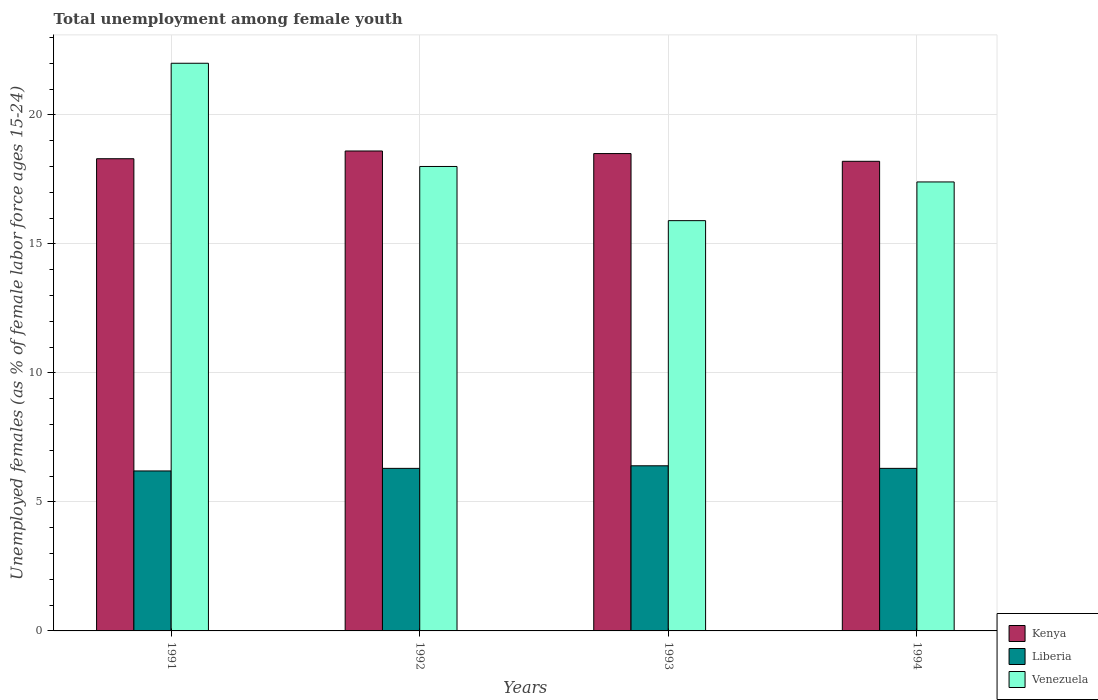Are the number of bars per tick equal to the number of legend labels?
Make the answer very short. Yes. Are the number of bars on each tick of the X-axis equal?
Your answer should be very brief. Yes. How many bars are there on the 3rd tick from the left?
Your answer should be compact. 3. How many bars are there on the 2nd tick from the right?
Your response must be concise. 3. In how many cases, is the number of bars for a given year not equal to the number of legend labels?
Ensure brevity in your answer.  0. What is the percentage of unemployed females in in Venezuela in 1991?
Keep it short and to the point. 22. Across all years, what is the maximum percentage of unemployed females in in Kenya?
Ensure brevity in your answer.  18.6. Across all years, what is the minimum percentage of unemployed females in in Liberia?
Offer a very short reply. 6.2. What is the total percentage of unemployed females in in Venezuela in the graph?
Your answer should be very brief. 73.3. What is the difference between the percentage of unemployed females in in Kenya in 1991 and that in 1994?
Offer a very short reply. 0.1. What is the difference between the percentage of unemployed females in in Kenya in 1992 and the percentage of unemployed females in in Liberia in 1991?
Offer a terse response. 12.4. What is the average percentage of unemployed females in in Kenya per year?
Keep it short and to the point. 18.4. In the year 1993, what is the difference between the percentage of unemployed females in in Liberia and percentage of unemployed females in in Kenya?
Your answer should be very brief. -12.1. In how many years, is the percentage of unemployed females in in Kenya greater than 18 %?
Provide a short and direct response. 4. What is the ratio of the percentage of unemployed females in in Venezuela in 1992 to that in 1994?
Ensure brevity in your answer.  1.03. Is the percentage of unemployed females in in Venezuela in 1992 less than that in 1993?
Your answer should be compact. No. Is the difference between the percentage of unemployed females in in Liberia in 1991 and 1994 greater than the difference between the percentage of unemployed females in in Kenya in 1991 and 1994?
Your answer should be compact. No. What is the difference between the highest and the second highest percentage of unemployed females in in Liberia?
Make the answer very short. 0.1. What is the difference between the highest and the lowest percentage of unemployed females in in Kenya?
Keep it short and to the point. 0.4. What does the 2nd bar from the left in 1992 represents?
Your answer should be very brief. Liberia. What does the 3rd bar from the right in 1994 represents?
Provide a short and direct response. Kenya. Is it the case that in every year, the sum of the percentage of unemployed females in in Liberia and percentage of unemployed females in in Kenya is greater than the percentage of unemployed females in in Venezuela?
Your answer should be compact. Yes. How many bars are there?
Your response must be concise. 12. Are all the bars in the graph horizontal?
Your answer should be compact. No. Are the values on the major ticks of Y-axis written in scientific E-notation?
Offer a terse response. No. Does the graph contain grids?
Offer a terse response. Yes. How are the legend labels stacked?
Offer a very short reply. Vertical. What is the title of the graph?
Give a very brief answer. Total unemployment among female youth. What is the label or title of the X-axis?
Ensure brevity in your answer.  Years. What is the label or title of the Y-axis?
Give a very brief answer. Unemployed females (as % of female labor force ages 15-24). What is the Unemployed females (as % of female labor force ages 15-24) in Kenya in 1991?
Provide a succinct answer. 18.3. What is the Unemployed females (as % of female labor force ages 15-24) of Liberia in 1991?
Your response must be concise. 6.2. What is the Unemployed females (as % of female labor force ages 15-24) of Venezuela in 1991?
Offer a very short reply. 22. What is the Unemployed females (as % of female labor force ages 15-24) in Kenya in 1992?
Make the answer very short. 18.6. What is the Unemployed females (as % of female labor force ages 15-24) in Liberia in 1992?
Keep it short and to the point. 6.3. What is the Unemployed females (as % of female labor force ages 15-24) of Kenya in 1993?
Offer a very short reply. 18.5. What is the Unemployed females (as % of female labor force ages 15-24) in Liberia in 1993?
Make the answer very short. 6.4. What is the Unemployed females (as % of female labor force ages 15-24) in Venezuela in 1993?
Your response must be concise. 15.9. What is the Unemployed females (as % of female labor force ages 15-24) of Kenya in 1994?
Your answer should be compact. 18.2. What is the Unemployed females (as % of female labor force ages 15-24) of Liberia in 1994?
Your answer should be very brief. 6.3. What is the Unemployed females (as % of female labor force ages 15-24) in Venezuela in 1994?
Keep it short and to the point. 17.4. Across all years, what is the maximum Unemployed females (as % of female labor force ages 15-24) in Kenya?
Offer a terse response. 18.6. Across all years, what is the maximum Unemployed females (as % of female labor force ages 15-24) in Liberia?
Give a very brief answer. 6.4. Across all years, what is the maximum Unemployed females (as % of female labor force ages 15-24) in Venezuela?
Your answer should be very brief. 22. Across all years, what is the minimum Unemployed females (as % of female labor force ages 15-24) in Kenya?
Give a very brief answer. 18.2. Across all years, what is the minimum Unemployed females (as % of female labor force ages 15-24) of Liberia?
Offer a terse response. 6.2. Across all years, what is the minimum Unemployed females (as % of female labor force ages 15-24) of Venezuela?
Your answer should be compact. 15.9. What is the total Unemployed females (as % of female labor force ages 15-24) in Kenya in the graph?
Offer a very short reply. 73.6. What is the total Unemployed females (as % of female labor force ages 15-24) of Liberia in the graph?
Provide a succinct answer. 25.2. What is the total Unemployed females (as % of female labor force ages 15-24) in Venezuela in the graph?
Give a very brief answer. 73.3. What is the difference between the Unemployed females (as % of female labor force ages 15-24) of Kenya in 1991 and that in 1992?
Give a very brief answer. -0.3. What is the difference between the Unemployed females (as % of female labor force ages 15-24) of Kenya in 1991 and that in 1993?
Your answer should be very brief. -0.2. What is the difference between the Unemployed females (as % of female labor force ages 15-24) in Kenya in 1992 and that in 1994?
Provide a short and direct response. 0.4. What is the difference between the Unemployed females (as % of female labor force ages 15-24) in Venezuela in 1992 and that in 1994?
Provide a succinct answer. 0.6. What is the difference between the Unemployed females (as % of female labor force ages 15-24) of Venezuela in 1993 and that in 1994?
Provide a short and direct response. -1.5. What is the difference between the Unemployed females (as % of female labor force ages 15-24) of Kenya in 1991 and the Unemployed females (as % of female labor force ages 15-24) of Liberia in 1992?
Offer a very short reply. 12. What is the difference between the Unemployed females (as % of female labor force ages 15-24) in Kenya in 1991 and the Unemployed females (as % of female labor force ages 15-24) in Venezuela in 1992?
Keep it short and to the point. 0.3. What is the difference between the Unemployed females (as % of female labor force ages 15-24) in Liberia in 1991 and the Unemployed females (as % of female labor force ages 15-24) in Venezuela in 1992?
Your answer should be compact. -11.8. What is the difference between the Unemployed females (as % of female labor force ages 15-24) of Kenya in 1991 and the Unemployed females (as % of female labor force ages 15-24) of Venezuela in 1993?
Offer a terse response. 2.4. What is the difference between the Unemployed females (as % of female labor force ages 15-24) of Liberia in 1991 and the Unemployed females (as % of female labor force ages 15-24) of Venezuela in 1993?
Provide a succinct answer. -9.7. What is the difference between the Unemployed females (as % of female labor force ages 15-24) of Kenya in 1991 and the Unemployed females (as % of female labor force ages 15-24) of Venezuela in 1994?
Provide a short and direct response. 0.9. What is the difference between the Unemployed females (as % of female labor force ages 15-24) of Kenya in 1992 and the Unemployed females (as % of female labor force ages 15-24) of Liberia in 1993?
Your response must be concise. 12.2. What is the difference between the Unemployed females (as % of female labor force ages 15-24) in Kenya in 1992 and the Unemployed females (as % of female labor force ages 15-24) in Venezuela in 1993?
Provide a short and direct response. 2.7. What is the difference between the Unemployed females (as % of female labor force ages 15-24) in Liberia in 1992 and the Unemployed females (as % of female labor force ages 15-24) in Venezuela in 1993?
Keep it short and to the point. -9.6. What is the difference between the Unemployed females (as % of female labor force ages 15-24) in Liberia in 1992 and the Unemployed females (as % of female labor force ages 15-24) in Venezuela in 1994?
Provide a short and direct response. -11.1. What is the difference between the Unemployed females (as % of female labor force ages 15-24) of Kenya in 1993 and the Unemployed females (as % of female labor force ages 15-24) of Liberia in 1994?
Your answer should be compact. 12.2. What is the average Unemployed females (as % of female labor force ages 15-24) in Kenya per year?
Ensure brevity in your answer.  18.4. What is the average Unemployed females (as % of female labor force ages 15-24) of Liberia per year?
Provide a succinct answer. 6.3. What is the average Unemployed females (as % of female labor force ages 15-24) of Venezuela per year?
Ensure brevity in your answer.  18.32. In the year 1991, what is the difference between the Unemployed females (as % of female labor force ages 15-24) of Kenya and Unemployed females (as % of female labor force ages 15-24) of Liberia?
Offer a very short reply. 12.1. In the year 1991, what is the difference between the Unemployed females (as % of female labor force ages 15-24) in Liberia and Unemployed females (as % of female labor force ages 15-24) in Venezuela?
Keep it short and to the point. -15.8. In the year 1992, what is the difference between the Unemployed females (as % of female labor force ages 15-24) of Kenya and Unemployed females (as % of female labor force ages 15-24) of Liberia?
Ensure brevity in your answer.  12.3. In the year 1992, what is the difference between the Unemployed females (as % of female labor force ages 15-24) of Liberia and Unemployed females (as % of female labor force ages 15-24) of Venezuela?
Offer a very short reply. -11.7. In the year 1993, what is the difference between the Unemployed females (as % of female labor force ages 15-24) of Kenya and Unemployed females (as % of female labor force ages 15-24) of Liberia?
Provide a short and direct response. 12.1. In the year 1994, what is the difference between the Unemployed females (as % of female labor force ages 15-24) of Kenya and Unemployed females (as % of female labor force ages 15-24) of Venezuela?
Your answer should be compact. 0.8. In the year 1994, what is the difference between the Unemployed females (as % of female labor force ages 15-24) of Liberia and Unemployed females (as % of female labor force ages 15-24) of Venezuela?
Keep it short and to the point. -11.1. What is the ratio of the Unemployed females (as % of female labor force ages 15-24) in Kenya in 1991 to that in 1992?
Give a very brief answer. 0.98. What is the ratio of the Unemployed females (as % of female labor force ages 15-24) of Liberia in 1991 to that in 1992?
Your response must be concise. 0.98. What is the ratio of the Unemployed females (as % of female labor force ages 15-24) of Venezuela in 1991 to that in 1992?
Ensure brevity in your answer.  1.22. What is the ratio of the Unemployed females (as % of female labor force ages 15-24) in Liberia in 1991 to that in 1993?
Ensure brevity in your answer.  0.97. What is the ratio of the Unemployed females (as % of female labor force ages 15-24) of Venezuela in 1991 to that in 1993?
Your answer should be very brief. 1.38. What is the ratio of the Unemployed females (as % of female labor force ages 15-24) in Liberia in 1991 to that in 1994?
Keep it short and to the point. 0.98. What is the ratio of the Unemployed females (as % of female labor force ages 15-24) in Venezuela in 1991 to that in 1994?
Ensure brevity in your answer.  1.26. What is the ratio of the Unemployed females (as % of female labor force ages 15-24) of Kenya in 1992 to that in 1993?
Offer a very short reply. 1.01. What is the ratio of the Unemployed females (as % of female labor force ages 15-24) of Liberia in 1992 to that in 1993?
Make the answer very short. 0.98. What is the ratio of the Unemployed females (as % of female labor force ages 15-24) of Venezuela in 1992 to that in 1993?
Keep it short and to the point. 1.13. What is the ratio of the Unemployed females (as % of female labor force ages 15-24) of Liberia in 1992 to that in 1994?
Offer a terse response. 1. What is the ratio of the Unemployed females (as % of female labor force ages 15-24) of Venezuela in 1992 to that in 1994?
Provide a short and direct response. 1.03. What is the ratio of the Unemployed females (as % of female labor force ages 15-24) in Kenya in 1993 to that in 1994?
Offer a very short reply. 1.02. What is the ratio of the Unemployed females (as % of female labor force ages 15-24) of Liberia in 1993 to that in 1994?
Ensure brevity in your answer.  1.02. What is the ratio of the Unemployed females (as % of female labor force ages 15-24) of Venezuela in 1993 to that in 1994?
Make the answer very short. 0.91. What is the difference between the highest and the lowest Unemployed females (as % of female labor force ages 15-24) of Kenya?
Your answer should be compact. 0.4. 